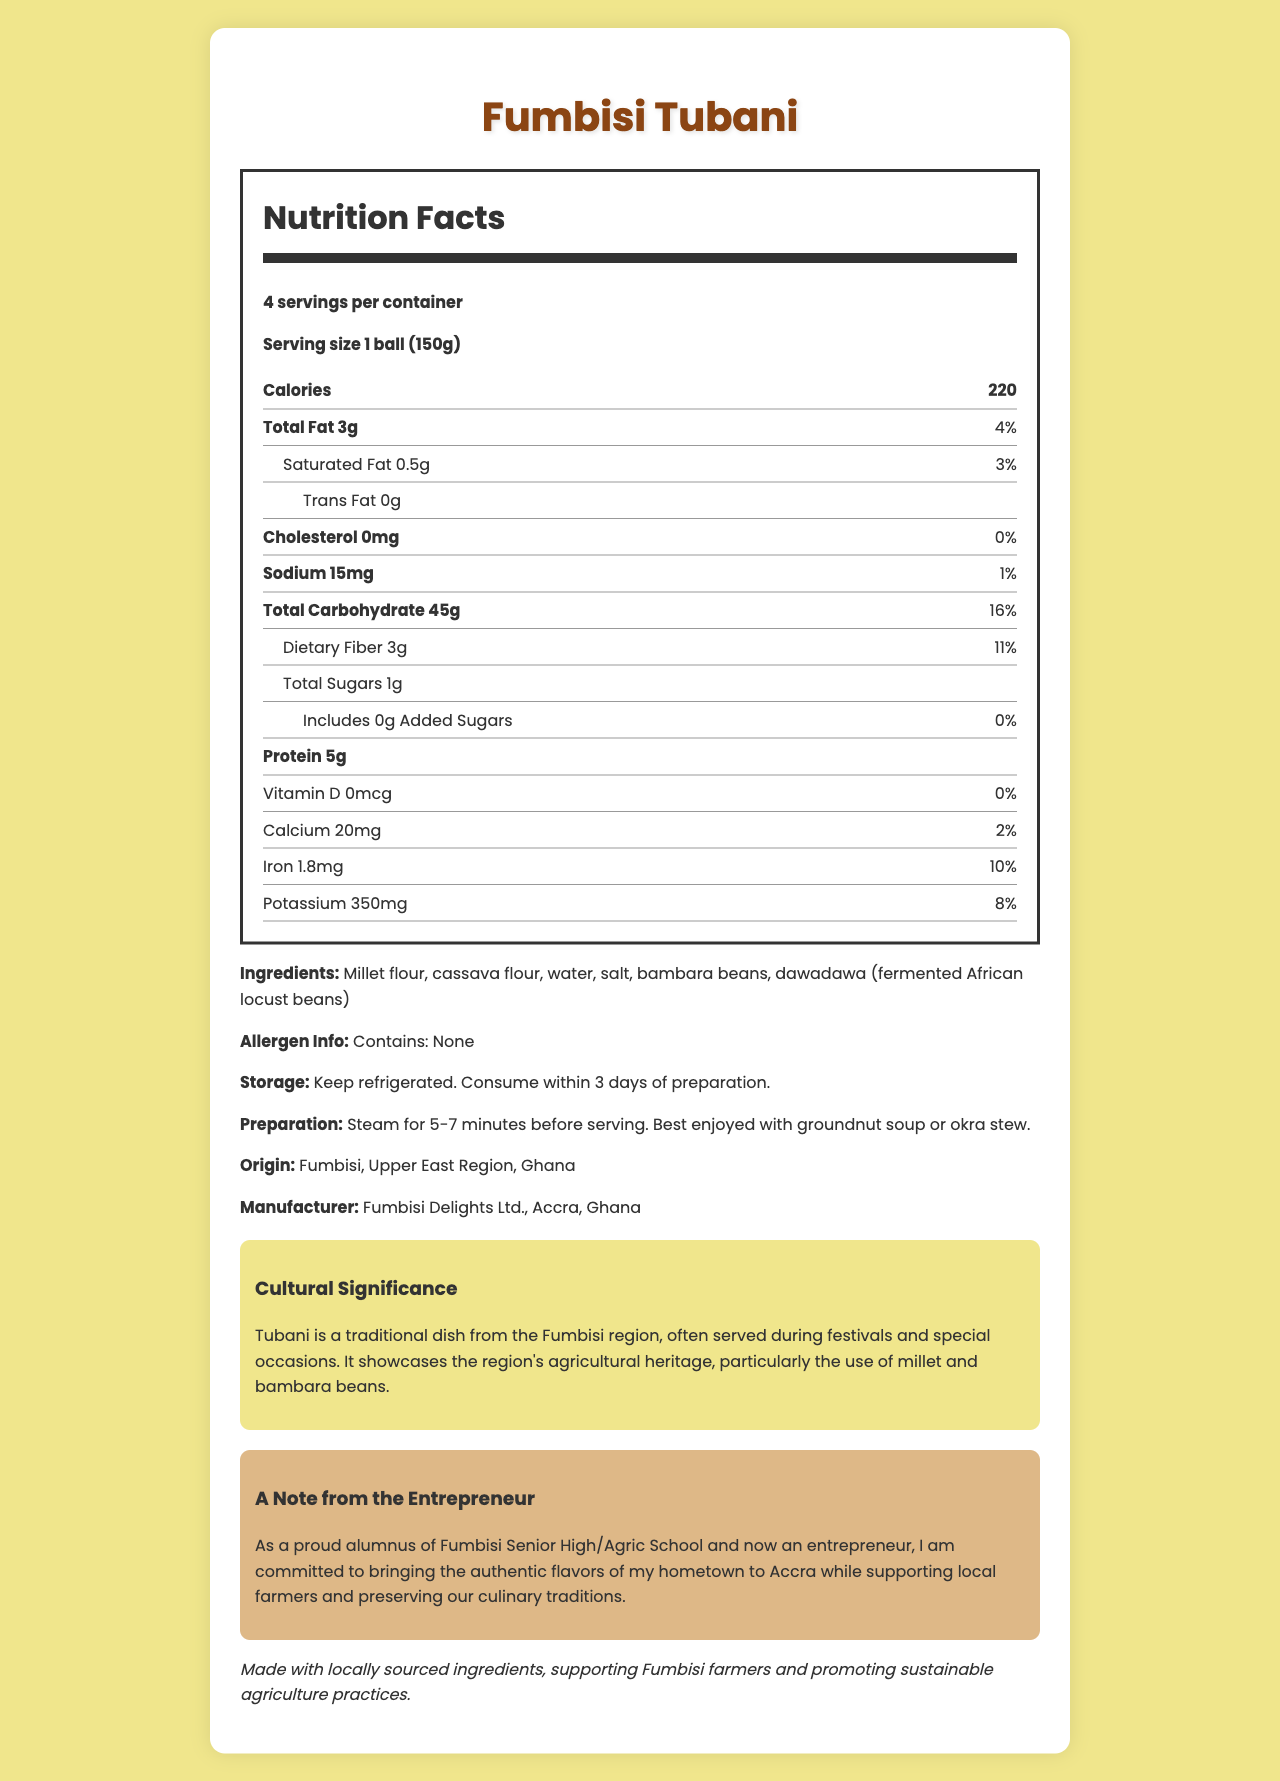what is the serving size for Fumbisi Tubani? The serving size is explicitly stated on the nutrition label as "1 ball (150g)".
Answer: 1 ball (150g) how many servings are in one container? The nutrition label states there are 4 servings per container.
Answer: 4 how many calories are in one serving of Fumbisi Tubani? The nutrition label shows that each serving size has 220 calories.
Answer: 220 what is the total carbohydrate content per serving? The nutrition label displays that the total carbohydrate content per serving is 45g.
Answer: 45g what are the storage instructions for Fumbisi Tubani? The storage instructions are listed at the end of the document, stating to keep the product refrigerated and consume within 3 days of preparation.
Answer: Keep refrigerated. Consume within 3 days of preparation. what are the main ingredients in Fumbisi Tubani? A. Millet flour, cassava flour, water, salt B. Bambara beans, dawadawa, millet flour C. Millet flour, cassava flour, bambara beans, dawadawa The ingredients listed are "Millet flour, cassava flour, water, salt, bambara beans, dawadawa (fermented African locust beans)".
Answer: C how much protein does one serving of Fumbisi Tubani contain? According to the nutrition label, one serving contains 5g of protein.
Answer: 5g how much dietary fiber is in a serving, and what percentage of the daily value does this represent? The nutrition label specifies that one serving contains 3g of dietary fiber, which represents 11% of the daily value.
Answer: 3g, 11% is there any cholesterol in Fumbisi Tubani? The nutrition label indicates that Fumbisi Tubani contains 0mg cholesterol, which equals 0% of the daily value.
Answer: No Based on the document, what is the cultural significance of Fumbisi Tubani? A. It is consumed daily by locals B. It is a holiday treat C. It is often served during festivals and special occasions The document states that Tubani is a traditional dish often served during festivals and special occasions, highlighting its cultural significance.
Answer: C what mineral found in Fumbisi Tubani contributes 10% of the daily value? According to the nutrition label, one serving contains 1.8mg of iron, which accounts for 10% of the daily value.
Answer: Iron Evaluate this statement: "Fumbisi Tubani contains added sugars." The nutrition label shows that Fumbisi Tubani includes 0g of added sugars.
Answer: False summarize the main idea of the document. The document outlines all integral details about Fumbisi Tubani, focusing on its nutritional profile, ingredients, cultural context, and entrepreneurial commitment toward cultural preservation and sustainability.
Answer: The document provides comprehensive nutritional information about Fumbisi Tubani, a traditional dish from Fumbisi in Ghana. It highlights its ingredients, serving size, nutritional content, cultural significance, preparation, storage instructions, and sustainability note. Additionally, it includes a note from the entrepreneur who aims to promote local culinary traditions and support local farmers. how long should Fumbisi Tubani be steamed before serving? The preparation instructions at the end of the document recommend steaming the Tubani for 5-7 minutes before serving.
Answer: 5-7 minutes where is Fumbisi Tubani manufactured? The manufacturer is listed as Fumbisi Delights Ltd., Accra, Ghana.
Answer: Accra, Ghana Based on the nutritional information, can you determine if Fumbisi Tubani is gluten-free? The document does not provide specific information about gluten content or the presence of gluten-containing ingredients, so it cannot be determined if Fumbisi Tubani is gluten-free.
Answer: Cannot be determined 